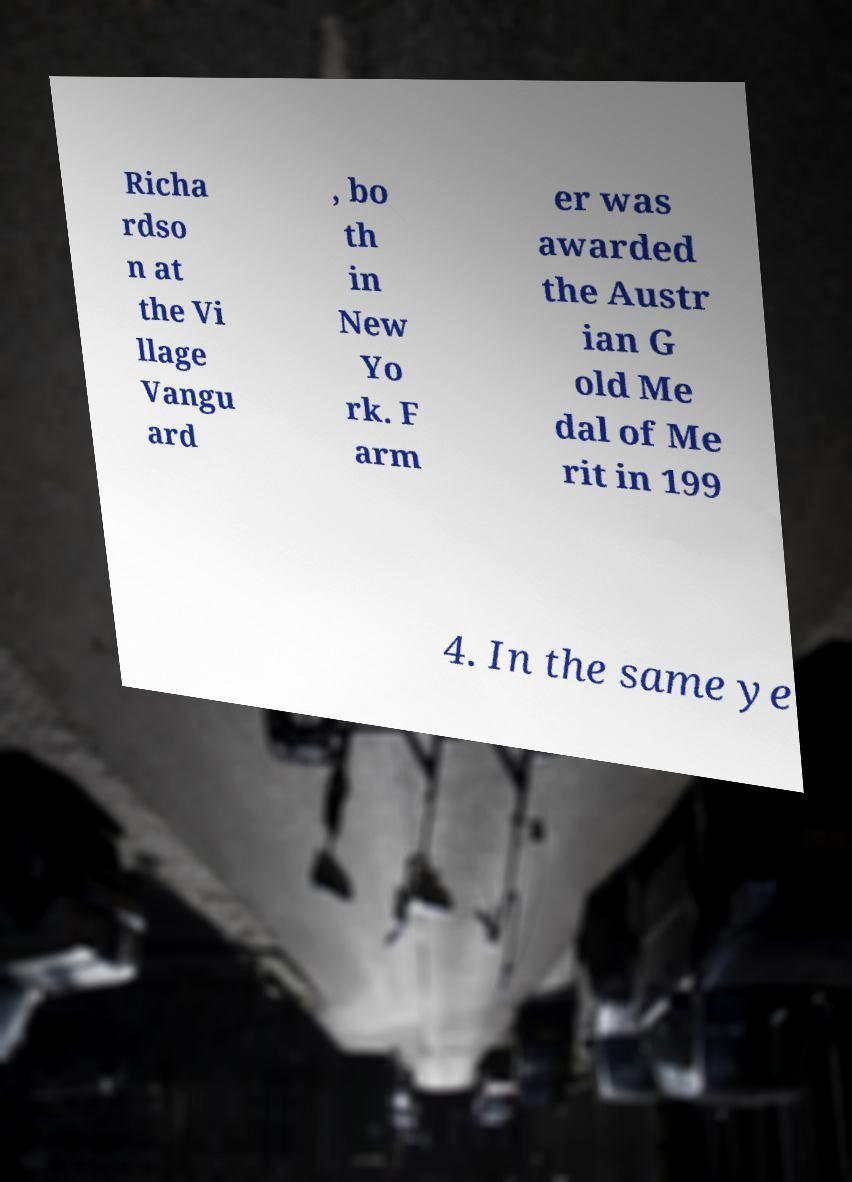What messages or text are displayed in this image? I need them in a readable, typed format. Richa rdso n at the Vi llage Vangu ard , bo th in New Yo rk. F arm er was awarded the Austr ian G old Me dal of Me rit in 199 4. In the same ye 